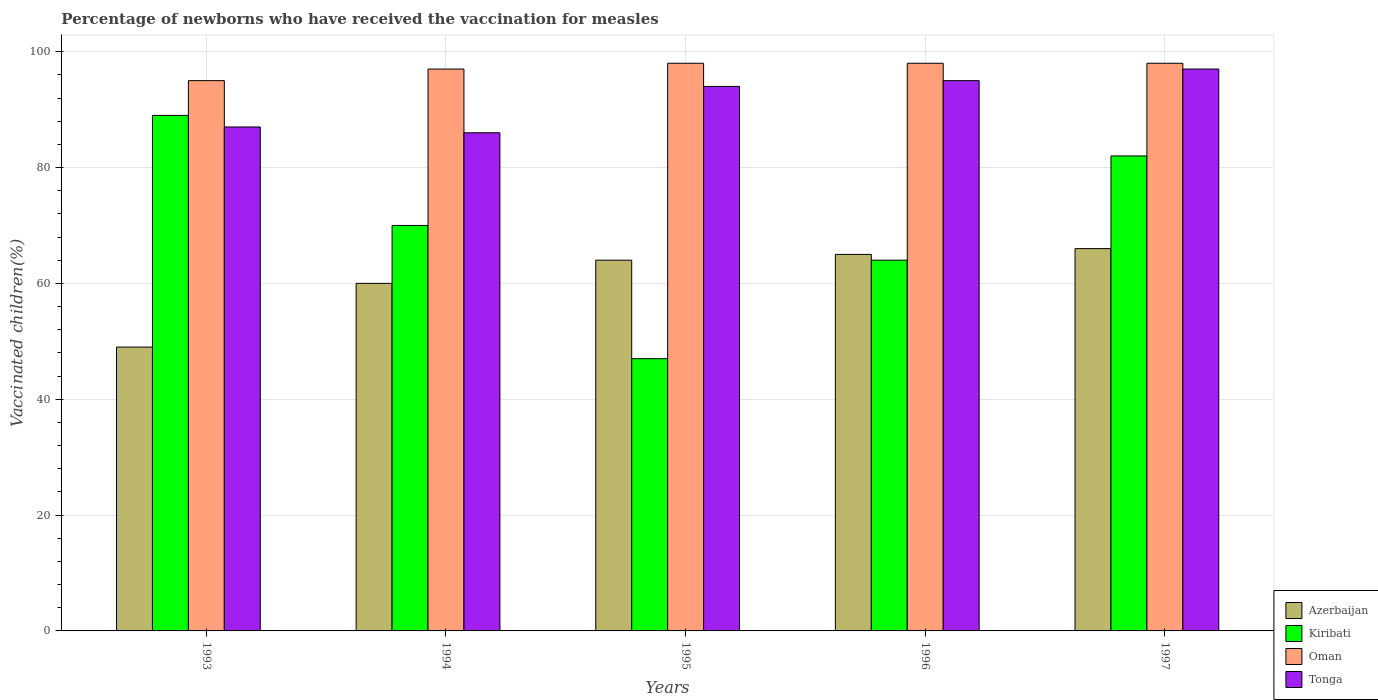How many different coloured bars are there?
Offer a terse response. 4. How many groups of bars are there?
Your response must be concise. 5. How many bars are there on the 4th tick from the left?
Provide a succinct answer. 4. How many bars are there on the 4th tick from the right?
Offer a very short reply. 4. In how many cases, is the number of bars for a given year not equal to the number of legend labels?
Keep it short and to the point. 0. What is the percentage of vaccinated children in Tonga in 1997?
Your answer should be very brief. 97. Across all years, what is the maximum percentage of vaccinated children in Kiribati?
Your response must be concise. 89. In which year was the percentage of vaccinated children in Oman maximum?
Offer a terse response. 1995. What is the total percentage of vaccinated children in Oman in the graph?
Provide a short and direct response. 486. What is the difference between the percentage of vaccinated children in Oman in 1997 and the percentage of vaccinated children in Azerbaijan in 1994?
Your response must be concise. 38. What is the average percentage of vaccinated children in Azerbaijan per year?
Ensure brevity in your answer.  60.8. In how many years, is the percentage of vaccinated children in Oman greater than 56 %?
Your answer should be compact. 5. What is the ratio of the percentage of vaccinated children in Azerbaijan in 1994 to that in 1996?
Your answer should be compact. 0.92. Is the difference between the percentage of vaccinated children in Kiribati in 1994 and 1997 greater than the difference between the percentage of vaccinated children in Azerbaijan in 1994 and 1997?
Provide a succinct answer. No. What is the difference between the highest and the lowest percentage of vaccinated children in Tonga?
Provide a short and direct response. 11. Is it the case that in every year, the sum of the percentage of vaccinated children in Azerbaijan and percentage of vaccinated children in Tonga is greater than the sum of percentage of vaccinated children in Oman and percentage of vaccinated children in Kiribati?
Your answer should be very brief. Yes. What does the 3rd bar from the left in 1993 represents?
Provide a succinct answer. Oman. What does the 2nd bar from the right in 1994 represents?
Provide a short and direct response. Oman. Is it the case that in every year, the sum of the percentage of vaccinated children in Azerbaijan and percentage of vaccinated children in Kiribati is greater than the percentage of vaccinated children in Tonga?
Ensure brevity in your answer.  Yes. Are the values on the major ticks of Y-axis written in scientific E-notation?
Your response must be concise. No. What is the title of the graph?
Provide a succinct answer. Percentage of newborns who have received the vaccination for measles. What is the label or title of the Y-axis?
Offer a terse response. Vaccinated children(%). What is the Vaccinated children(%) of Azerbaijan in 1993?
Your response must be concise. 49. What is the Vaccinated children(%) in Kiribati in 1993?
Keep it short and to the point. 89. What is the Vaccinated children(%) of Tonga in 1993?
Your answer should be very brief. 87. What is the Vaccinated children(%) of Kiribati in 1994?
Your answer should be compact. 70. What is the Vaccinated children(%) in Oman in 1994?
Give a very brief answer. 97. What is the Vaccinated children(%) in Tonga in 1995?
Ensure brevity in your answer.  94. What is the Vaccinated children(%) in Azerbaijan in 1996?
Ensure brevity in your answer.  65. What is the Vaccinated children(%) of Tonga in 1996?
Provide a succinct answer. 95. What is the Vaccinated children(%) of Oman in 1997?
Keep it short and to the point. 98. What is the Vaccinated children(%) in Tonga in 1997?
Your answer should be compact. 97. Across all years, what is the maximum Vaccinated children(%) in Azerbaijan?
Keep it short and to the point. 66. Across all years, what is the maximum Vaccinated children(%) in Kiribati?
Give a very brief answer. 89. Across all years, what is the maximum Vaccinated children(%) in Oman?
Offer a very short reply. 98. Across all years, what is the maximum Vaccinated children(%) of Tonga?
Keep it short and to the point. 97. Across all years, what is the minimum Vaccinated children(%) in Kiribati?
Your response must be concise. 47. Across all years, what is the minimum Vaccinated children(%) in Oman?
Your answer should be very brief. 95. What is the total Vaccinated children(%) of Azerbaijan in the graph?
Make the answer very short. 304. What is the total Vaccinated children(%) of Kiribati in the graph?
Ensure brevity in your answer.  352. What is the total Vaccinated children(%) in Oman in the graph?
Make the answer very short. 486. What is the total Vaccinated children(%) of Tonga in the graph?
Offer a very short reply. 459. What is the difference between the Vaccinated children(%) in Azerbaijan in 1993 and that in 1994?
Ensure brevity in your answer.  -11. What is the difference between the Vaccinated children(%) of Oman in 1993 and that in 1994?
Your response must be concise. -2. What is the difference between the Vaccinated children(%) of Tonga in 1993 and that in 1994?
Your answer should be compact. 1. What is the difference between the Vaccinated children(%) in Kiribati in 1993 and that in 1995?
Make the answer very short. 42. What is the difference between the Vaccinated children(%) in Oman in 1993 and that in 1995?
Ensure brevity in your answer.  -3. What is the difference between the Vaccinated children(%) in Tonga in 1993 and that in 1996?
Offer a very short reply. -8. What is the difference between the Vaccinated children(%) in Kiribati in 1993 and that in 1997?
Provide a succinct answer. 7. What is the difference between the Vaccinated children(%) in Oman in 1993 and that in 1997?
Provide a succinct answer. -3. What is the difference between the Vaccinated children(%) in Oman in 1994 and that in 1995?
Your answer should be very brief. -1. What is the difference between the Vaccinated children(%) of Azerbaijan in 1994 and that in 1997?
Make the answer very short. -6. What is the difference between the Vaccinated children(%) of Kiribati in 1994 and that in 1997?
Provide a succinct answer. -12. What is the difference between the Vaccinated children(%) of Oman in 1994 and that in 1997?
Offer a terse response. -1. What is the difference between the Vaccinated children(%) of Tonga in 1995 and that in 1996?
Ensure brevity in your answer.  -1. What is the difference between the Vaccinated children(%) in Kiribati in 1995 and that in 1997?
Give a very brief answer. -35. What is the difference between the Vaccinated children(%) of Tonga in 1995 and that in 1997?
Give a very brief answer. -3. What is the difference between the Vaccinated children(%) in Azerbaijan in 1996 and that in 1997?
Ensure brevity in your answer.  -1. What is the difference between the Vaccinated children(%) of Kiribati in 1996 and that in 1997?
Make the answer very short. -18. What is the difference between the Vaccinated children(%) in Azerbaijan in 1993 and the Vaccinated children(%) in Kiribati in 1994?
Give a very brief answer. -21. What is the difference between the Vaccinated children(%) in Azerbaijan in 1993 and the Vaccinated children(%) in Oman in 1994?
Provide a succinct answer. -48. What is the difference between the Vaccinated children(%) in Azerbaijan in 1993 and the Vaccinated children(%) in Tonga in 1994?
Your answer should be compact. -37. What is the difference between the Vaccinated children(%) of Kiribati in 1993 and the Vaccinated children(%) of Oman in 1994?
Keep it short and to the point. -8. What is the difference between the Vaccinated children(%) of Oman in 1993 and the Vaccinated children(%) of Tonga in 1994?
Provide a short and direct response. 9. What is the difference between the Vaccinated children(%) in Azerbaijan in 1993 and the Vaccinated children(%) in Oman in 1995?
Offer a very short reply. -49. What is the difference between the Vaccinated children(%) in Azerbaijan in 1993 and the Vaccinated children(%) in Tonga in 1995?
Give a very brief answer. -45. What is the difference between the Vaccinated children(%) of Kiribati in 1993 and the Vaccinated children(%) of Tonga in 1995?
Provide a succinct answer. -5. What is the difference between the Vaccinated children(%) in Azerbaijan in 1993 and the Vaccinated children(%) in Oman in 1996?
Give a very brief answer. -49. What is the difference between the Vaccinated children(%) of Azerbaijan in 1993 and the Vaccinated children(%) of Tonga in 1996?
Give a very brief answer. -46. What is the difference between the Vaccinated children(%) of Kiribati in 1993 and the Vaccinated children(%) of Tonga in 1996?
Your response must be concise. -6. What is the difference between the Vaccinated children(%) of Oman in 1993 and the Vaccinated children(%) of Tonga in 1996?
Provide a succinct answer. 0. What is the difference between the Vaccinated children(%) in Azerbaijan in 1993 and the Vaccinated children(%) in Kiribati in 1997?
Give a very brief answer. -33. What is the difference between the Vaccinated children(%) of Azerbaijan in 1993 and the Vaccinated children(%) of Oman in 1997?
Provide a succinct answer. -49. What is the difference between the Vaccinated children(%) of Azerbaijan in 1993 and the Vaccinated children(%) of Tonga in 1997?
Ensure brevity in your answer.  -48. What is the difference between the Vaccinated children(%) in Azerbaijan in 1994 and the Vaccinated children(%) in Kiribati in 1995?
Ensure brevity in your answer.  13. What is the difference between the Vaccinated children(%) of Azerbaijan in 1994 and the Vaccinated children(%) of Oman in 1995?
Offer a terse response. -38. What is the difference between the Vaccinated children(%) of Azerbaijan in 1994 and the Vaccinated children(%) of Tonga in 1995?
Make the answer very short. -34. What is the difference between the Vaccinated children(%) in Azerbaijan in 1994 and the Vaccinated children(%) in Kiribati in 1996?
Your answer should be very brief. -4. What is the difference between the Vaccinated children(%) of Azerbaijan in 1994 and the Vaccinated children(%) of Oman in 1996?
Your answer should be very brief. -38. What is the difference between the Vaccinated children(%) in Azerbaijan in 1994 and the Vaccinated children(%) in Tonga in 1996?
Your answer should be compact. -35. What is the difference between the Vaccinated children(%) in Oman in 1994 and the Vaccinated children(%) in Tonga in 1996?
Offer a very short reply. 2. What is the difference between the Vaccinated children(%) of Azerbaijan in 1994 and the Vaccinated children(%) of Kiribati in 1997?
Give a very brief answer. -22. What is the difference between the Vaccinated children(%) in Azerbaijan in 1994 and the Vaccinated children(%) in Oman in 1997?
Provide a short and direct response. -38. What is the difference between the Vaccinated children(%) in Azerbaijan in 1994 and the Vaccinated children(%) in Tonga in 1997?
Offer a very short reply. -37. What is the difference between the Vaccinated children(%) of Kiribati in 1994 and the Vaccinated children(%) of Oman in 1997?
Ensure brevity in your answer.  -28. What is the difference between the Vaccinated children(%) of Oman in 1994 and the Vaccinated children(%) of Tonga in 1997?
Your answer should be compact. 0. What is the difference between the Vaccinated children(%) in Azerbaijan in 1995 and the Vaccinated children(%) in Oman in 1996?
Give a very brief answer. -34. What is the difference between the Vaccinated children(%) of Azerbaijan in 1995 and the Vaccinated children(%) of Tonga in 1996?
Ensure brevity in your answer.  -31. What is the difference between the Vaccinated children(%) of Kiribati in 1995 and the Vaccinated children(%) of Oman in 1996?
Make the answer very short. -51. What is the difference between the Vaccinated children(%) of Kiribati in 1995 and the Vaccinated children(%) of Tonga in 1996?
Provide a succinct answer. -48. What is the difference between the Vaccinated children(%) of Oman in 1995 and the Vaccinated children(%) of Tonga in 1996?
Make the answer very short. 3. What is the difference between the Vaccinated children(%) of Azerbaijan in 1995 and the Vaccinated children(%) of Kiribati in 1997?
Offer a very short reply. -18. What is the difference between the Vaccinated children(%) in Azerbaijan in 1995 and the Vaccinated children(%) in Oman in 1997?
Keep it short and to the point. -34. What is the difference between the Vaccinated children(%) in Azerbaijan in 1995 and the Vaccinated children(%) in Tonga in 1997?
Your answer should be very brief. -33. What is the difference between the Vaccinated children(%) of Kiribati in 1995 and the Vaccinated children(%) of Oman in 1997?
Offer a very short reply. -51. What is the difference between the Vaccinated children(%) in Kiribati in 1995 and the Vaccinated children(%) in Tonga in 1997?
Your response must be concise. -50. What is the difference between the Vaccinated children(%) of Oman in 1995 and the Vaccinated children(%) of Tonga in 1997?
Your response must be concise. 1. What is the difference between the Vaccinated children(%) of Azerbaijan in 1996 and the Vaccinated children(%) of Kiribati in 1997?
Your answer should be very brief. -17. What is the difference between the Vaccinated children(%) of Azerbaijan in 1996 and the Vaccinated children(%) of Oman in 1997?
Give a very brief answer. -33. What is the difference between the Vaccinated children(%) in Azerbaijan in 1996 and the Vaccinated children(%) in Tonga in 1997?
Ensure brevity in your answer.  -32. What is the difference between the Vaccinated children(%) in Kiribati in 1996 and the Vaccinated children(%) in Oman in 1997?
Offer a very short reply. -34. What is the difference between the Vaccinated children(%) in Kiribati in 1996 and the Vaccinated children(%) in Tonga in 1997?
Keep it short and to the point. -33. What is the difference between the Vaccinated children(%) in Oman in 1996 and the Vaccinated children(%) in Tonga in 1997?
Give a very brief answer. 1. What is the average Vaccinated children(%) in Azerbaijan per year?
Keep it short and to the point. 60.8. What is the average Vaccinated children(%) of Kiribati per year?
Your response must be concise. 70.4. What is the average Vaccinated children(%) of Oman per year?
Your response must be concise. 97.2. What is the average Vaccinated children(%) of Tonga per year?
Provide a short and direct response. 91.8. In the year 1993, what is the difference between the Vaccinated children(%) in Azerbaijan and Vaccinated children(%) in Kiribati?
Make the answer very short. -40. In the year 1993, what is the difference between the Vaccinated children(%) in Azerbaijan and Vaccinated children(%) in Oman?
Give a very brief answer. -46. In the year 1993, what is the difference between the Vaccinated children(%) in Azerbaijan and Vaccinated children(%) in Tonga?
Your answer should be very brief. -38. In the year 1993, what is the difference between the Vaccinated children(%) in Kiribati and Vaccinated children(%) in Oman?
Offer a terse response. -6. In the year 1994, what is the difference between the Vaccinated children(%) in Azerbaijan and Vaccinated children(%) in Kiribati?
Ensure brevity in your answer.  -10. In the year 1994, what is the difference between the Vaccinated children(%) in Azerbaijan and Vaccinated children(%) in Oman?
Give a very brief answer. -37. In the year 1994, what is the difference between the Vaccinated children(%) of Kiribati and Vaccinated children(%) of Oman?
Make the answer very short. -27. In the year 1994, what is the difference between the Vaccinated children(%) in Oman and Vaccinated children(%) in Tonga?
Keep it short and to the point. 11. In the year 1995, what is the difference between the Vaccinated children(%) of Azerbaijan and Vaccinated children(%) of Kiribati?
Offer a very short reply. 17. In the year 1995, what is the difference between the Vaccinated children(%) in Azerbaijan and Vaccinated children(%) in Oman?
Give a very brief answer. -34. In the year 1995, what is the difference between the Vaccinated children(%) of Kiribati and Vaccinated children(%) of Oman?
Make the answer very short. -51. In the year 1995, what is the difference between the Vaccinated children(%) in Kiribati and Vaccinated children(%) in Tonga?
Give a very brief answer. -47. In the year 1995, what is the difference between the Vaccinated children(%) of Oman and Vaccinated children(%) of Tonga?
Your answer should be compact. 4. In the year 1996, what is the difference between the Vaccinated children(%) of Azerbaijan and Vaccinated children(%) of Kiribati?
Ensure brevity in your answer.  1. In the year 1996, what is the difference between the Vaccinated children(%) of Azerbaijan and Vaccinated children(%) of Oman?
Your response must be concise. -33. In the year 1996, what is the difference between the Vaccinated children(%) of Azerbaijan and Vaccinated children(%) of Tonga?
Provide a succinct answer. -30. In the year 1996, what is the difference between the Vaccinated children(%) of Kiribati and Vaccinated children(%) of Oman?
Your answer should be very brief. -34. In the year 1996, what is the difference between the Vaccinated children(%) of Kiribati and Vaccinated children(%) of Tonga?
Ensure brevity in your answer.  -31. In the year 1997, what is the difference between the Vaccinated children(%) in Azerbaijan and Vaccinated children(%) in Oman?
Ensure brevity in your answer.  -32. In the year 1997, what is the difference between the Vaccinated children(%) of Azerbaijan and Vaccinated children(%) of Tonga?
Offer a very short reply. -31. In the year 1997, what is the difference between the Vaccinated children(%) in Kiribati and Vaccinated children(%) in Tonga?
Your answer should be very brief. -15. In the year 1997, what is the difference between the Vaccinated children(%) in Oman and Vaccinated children(%) in Tonga?
Your answer should be compact. 1. What is the ratio of the Vaccinated children(%) in Azerbaijan in 1993 to that in 1994?
Keep it short and to the point. 0.82. What is the ratio of the Vaccinated children(%) of Kiribati in 1993 to that in 1994?
Your answer should be compact. 1.27. What is the ratio of the Vaccinated children(%) in Oman in 1993 to that in 1994?
Your answer should be very brief. 0.98. What is the ratio of the Vaccinated children(%) in Tonga in 1993 to that in 1994?
Your response must be concise. 1.01. What is the ratio of the Vaccinated children(%) of Azerbaijan in 1993 to that in 1995?
Provide a succinct answer. 0.77. What is the ratio of the Vaccinated children(%) of Kiribati in 1993 to that in 1995?
Provide a short and direct response. 1.89. What is the ratio of the Vaccinated children(%) of Oman in 1993 to that in 1995?
Provide a short and direct response. 0.97. What is the ratio of the Vaccinated children(%) in Tonga in 1993 to that in 1995?
Provide a short and direct response. 0.93. What is the ratio of the Vaccinated children(%) of Azerbaijan in 1993 to that in 1996?
Offer a terse response. 0.75. What is the ratio of the Vaccinated children(%) of Kiribati in 1993 to that in 1996?
Give a very brief answer. 1.39. What is the ratio of the Vaccinated children(%) in Oman in 1993 to that in 1996?
Offer a terse response. 0.97. What is the ratio of the Vaccinated children(%) in Tonga in 1993 to that in 1996?
Your answer should be very brief. 0.92. What is the ratio of the Vaccinated children(%) of Azerbaijan in 1993 to that in 1997?
Offer a terse response. 0.74. What is the ratio of the Vaccinated children(%) in Kiribati in 1993 to that in 1997?
Your answer should be compact. 1.09. What is the ratio of the Vaccinated children(%) in Oman in 1993 to that in 1997?
Provide a short and direct response. 0.97. What is the ratio of the Vaccinated children(%) in Tonga in 1993 to that in 1997?
Keep it short and to the point. 0.9. What is the ratio of the Vaccinated children(%) of Kiribati in 1994 to that in 1995?
Provide a short and direct response. 1.49. What is the ratio of the Vaccinated children(%) of Oman in 1994 to that in 1995?
Ensure brevity in your answer.  0.99. What is the ratio of the Vaccinated children(%) in Tonga in 1994 to that in 1995?
Your response must be concise. 0.91. What is the ratio of the Vaccinated children(%) in Kiribati in 1994 to that in 1996?
Give a very brief answer. 1.09. What is the ratio of the Vaccinated children(%) of Tonga in 1994 to that in 1996?
Your answer should be very brief. 0.91. What is the ratio of the Vaccinated children(%) of Azerbaijan in 1994 to that in 1997?
Offer a very short reply. 0.91. What is the ratio of the Vaccinated children(%) of Kiribati in 1994 to that in 1997?
Your answer should be compact. 0.85. What is the ratio of the Vaccinated children(%) of Tonga in 1994 to that in 1997?
Make the answer very short. 0.89. What is the ratio of the Vaccinated children(%) of Azerbaijan in 1995 to that in 1996?
Offer a very short reply. 0.98. What is the ratio of the Vaccinated children(%) of Kiribati in 1995 to that in 1996?
Provide a succinct answer. 0.73. What is the ratio of the Vaccinated children(%) in Oman in 1995 to that in 1996?
Provide a succinct answer. 1. What is the ratio of the Vaccinated children(%) of Azerbaijan in 1995 to that in 1997?
Give a very brief answer. 0.97. What is the ratio of the Vaccinated children(%) in Kiribati in 1995 to that in 1997?
Your answer should be very brief. 0.57. What is the ratio of the Vaccinated children(%) in Oman in 1995 to that in 1997?
Your answer should be very brief. 1. What is the ratio of the Vaccinated children(%) of Tonga in 1995 to that in 1997?
Give a very brief answer. 0.97. What is the ratio of the Vaccinated children(%) of Azerbaijan in 1996 to that in 1997?
Your answer should be very brief. 0.98. What is the ratio of the Vaccinated children(%) of Kiribati in 1996 to that in 1997?
Your answer should be very brief. 0.78. What is the ratio of the Vaccinated children(%) of Oman in 1996 to that in 1997?
Provide a short and direct response. 1. What is the ratio of the Vaccinated children(%) in Tonga in 1996 to that in 1997?
Your response must be concise. 0.98. What is the difference between the highest and the second highest Vaccinated children(%) of Azerbaijan?
Provide a short and direct response. 1. What is the difference between the highest and the second highest Vaccinated children(%) in Kiribati?
Give a very brief answer. 7. What is the difference between the highest and the second highest Vaccinated children(%) in Oman?
Keep it short and to the point. 0. What is the difference between the highest and the lowest Vaccinated children(%) of Azerbaijan?
Your answer should be compact. 17. What is the difference between the highest and the lowest Vaccinated children(%) in Oman?
Give a very brief answer. 3. 